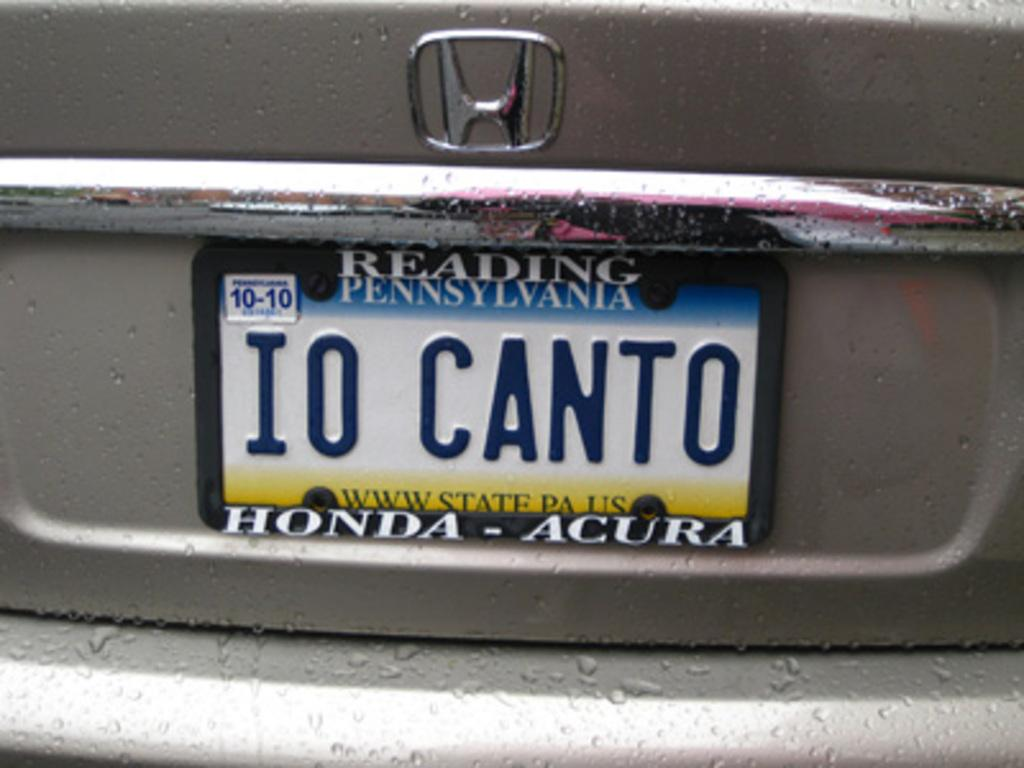<image>
Offer a succinct explanation of the picture presented. A license plate is from Pennsylvania and expires in October of 2010. 